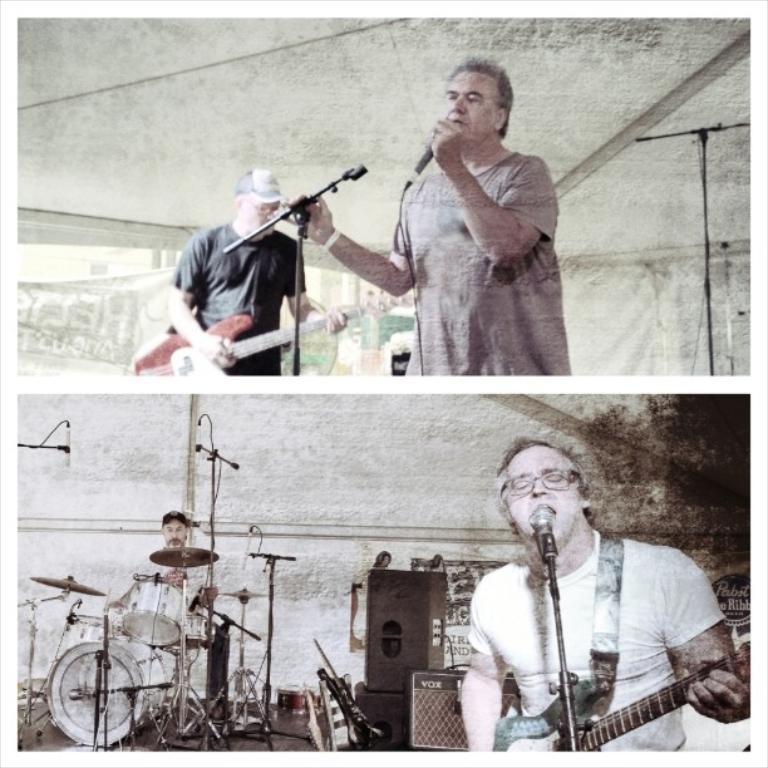Please provide a concise description of this image. This is an edited image. In the top image there are two people one of them is singing and the other one is playing guitar. In the bottom image there is a person he is playing guitar and singing he is on the right side on the left side he is playing drums there are speakers in the middle. 